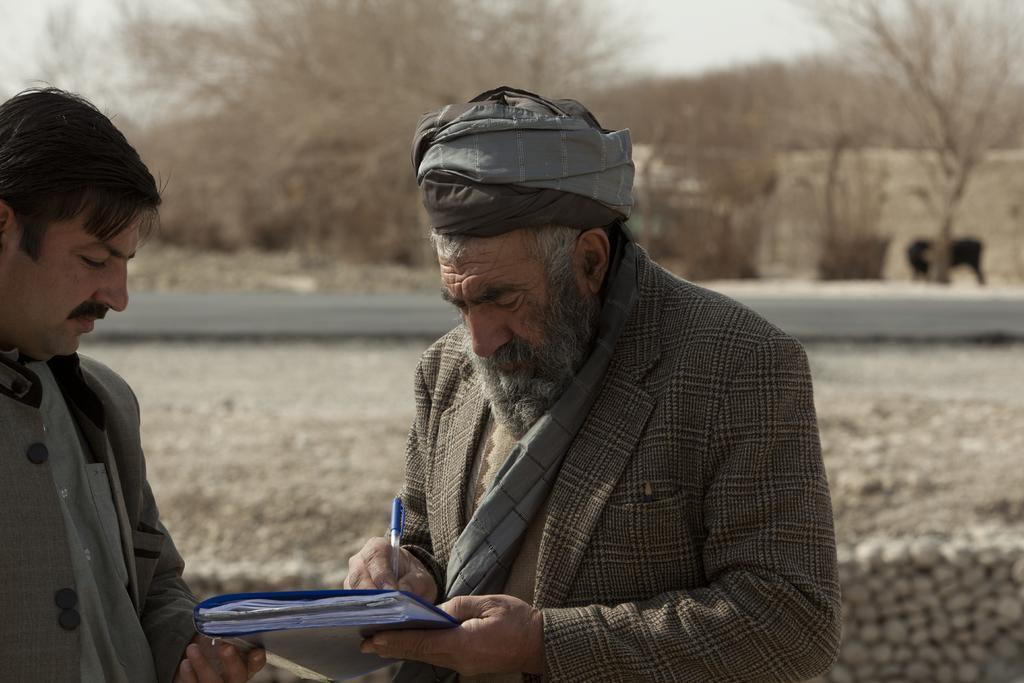How would you summarize this image in a sentence or two? In this image there is a person holding a book and writing with a pen on it, beside him there is another person standing. In the background there are trees and there is an animal. 